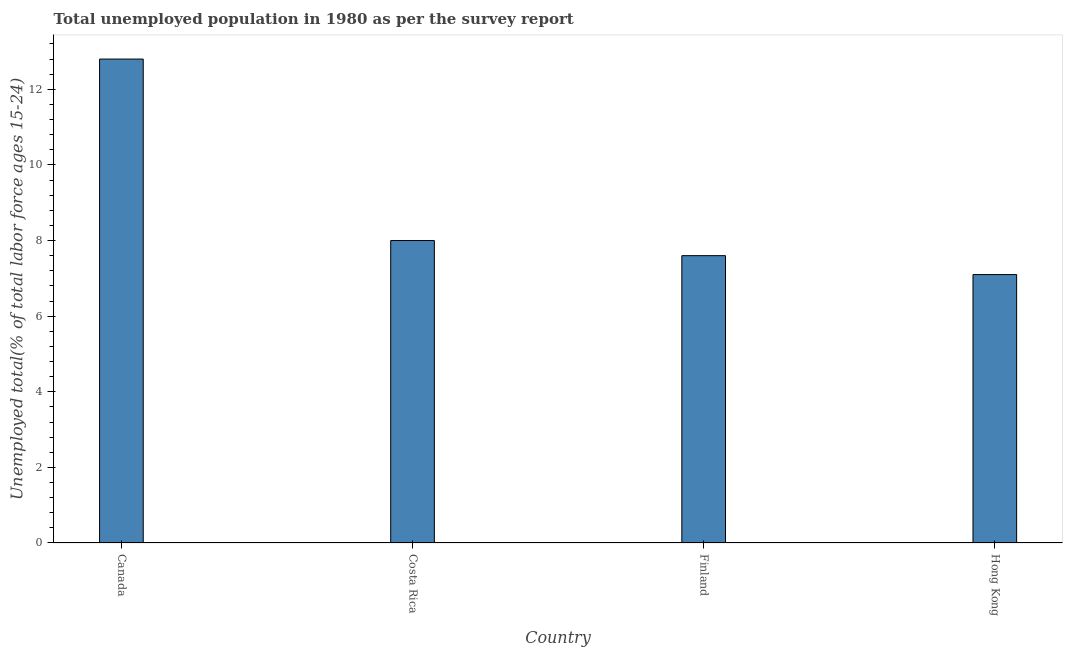Does the graph contain any zero values?
Ensure brevity in your answer.  No. What is the title of the graph?
Keep it short and to the point. Total unemployed population in 1980 as per the survey report. What is the label or title of the X-axis?
Ensure brevity in your answer.  Country. What is the label or title of the Y-axis?
Give a very brief answer. Unemployed total(% of total labor force ages 15-24). What is the unemployed youth in Costa Rica?
Your answer should be compact. 8. Across all countries, what is the maximum unemployed youth?
Make the answer very short. 12.8. Across all countries, what is the minimum unemployed youth?
Your response must be concise. 7.1. In which country was the unemployed youth minimum?
Make the answer very short. Hong Kong. What is the sum of the unemployed youth?
Offer a terse response. 35.5. What is the difference between the unemployed youth in Canada and Costa Rica?
Provide a succinct answer. 4.8. What is the average unemployed youth per country?
Offer a very short reply. 8.88. What is the median unemployed youth?
Keep it short and to the point. 7.8. In how many countries, is the unemployed youth greater than 4.4 %?
Your answer should be compact. 4. What is the ratio of the unemployed youth in Canada to that in Hong Kong?
Offer a terse response. 1.8. Is the difference between the unemployed youth in Canada and Finland greater than the difference between any two countries?
Your answer should be compact. No. What is the difference between the highest and the second highest unemployed youth?
Make the answer very short. 4.8. What is the difference between two consecutive major ticks on the Y-axis?
Offer a terse response. 2. What is the Unemployed total(% of total labor force ages 15-24) in Canada?
Provide a short and direct response. 12.8. What is the Unemployed total(% of total labor force ages 15-24) of Costa Rica?
Keep it short and to the point. 8. What is the Unemployed total(% of total labor force ages 15-24) of Finland?
Your response must be concise. 7.6. What is the Unemployed total(% of total labor force ages 15-24) of Hong Kong?
Your response must be concise. 7.1. What is the difference between the Unemployed total(% of total labor force ages 15-24) in Canada and Costa Rica?
Give a very brief answer. 4.8. What is the difference between the Unemployed total(% of total labor force ages 15-24) in Canada and Finland?
Give a very brief answer. 5.2. What is the difference between the Unemployed total(% of total labor force ages 15-24) in Costa Rica and Finland?
Give a very brief answer. 0.4. What is the difference between the Unemployed total(% of total labor force ages 15-24) in Costa Rica and Hong Kong?
Your answer should be compact. 0.9. What is the ratio of the Unemployed total(% of total labor force ages 15-24) in Canada to that in Finland?
Your answer should be compact. 1.68. What is the ratio of the Unemployed total(% of total labor force ages 15-24) in Canada to that in Hong Kong?
Offer a very short reply. 1.8. What is the ratio of the Unemployed total(% of total labor force ages 15-24) in Costa Rica to that in Finland?
Offer a very short reply. 1.05. What is the ratio of the Unemployed total(% of total labor force ages 15-24) in Costa Rica to that in Hong Kong?
Make the answer very short. 1.13. What is the ratio of the Unemployed total(% of total labor force ages 15-24) in Finland to that in Hong Kong?
Provide a succinct answer. 1.07. 